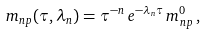Convert formula to latex. <formula><loc_0><loc_0><loc_500><loc_500>m _ { n p } ( \tau , \lambda _ { n } ) = \tau ^ { - n } \, e ^ { - \lambda _ { n } \tau } \, m _ { n p } ^ { 0 } \, ,</formula> 